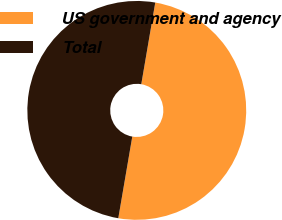Convert chart to OTSL. <chart><loc_0><loc_0><loc_500><loc_500><pie_chart><fcel>US government and agency<fcel>Total<nl><fcel>50.0%<fcel>50.0%<nl></chart> 